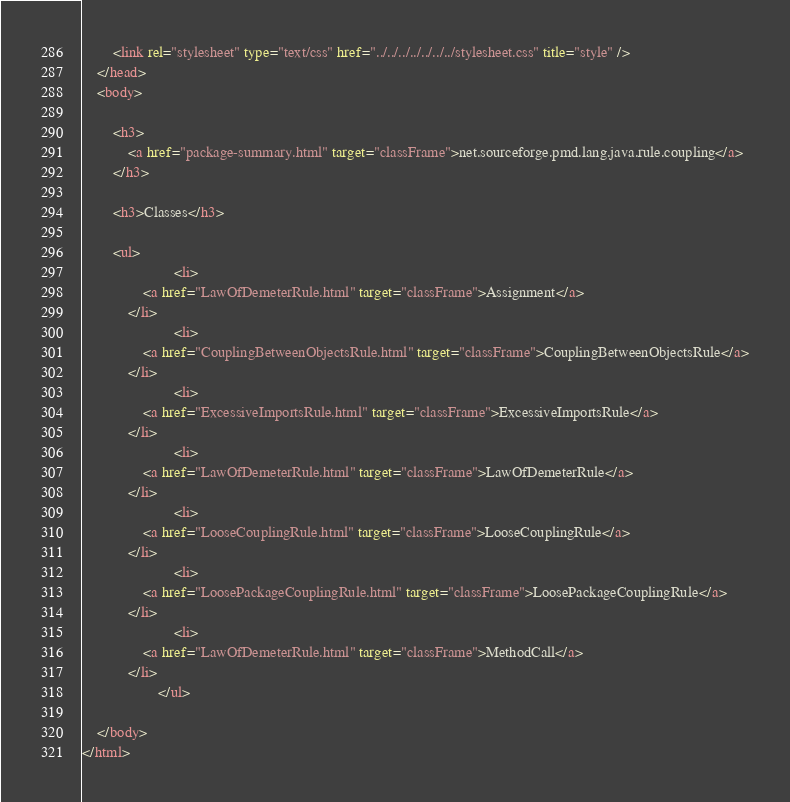Convert code to text. <code><loc_0><loc_0><loc_500><loc_500><_HTML_>		<link rel="stylesheet" type="text/css" href="../../../../../../../stylesheet.css" title="style" />
	</head>
	<body>

		<h3>
        	<a href="package-summary.html" target="classFrame">net.sourceforge.pmd.lang.java.rule.coupling</a>
      	</h3>

      	<h3>Classes</h3>

      	<ul>
      		          	<li>
            	<a href="LawOfDemeterRule.html" target="classFrame">Assignment</a>
          	</li>
          	          	<li>
            	<a href="CouplingBetweenObjectsRule.html" target="classFrame">CouplingBetweenObjectsRule</a>
          	</li>
          	          	<li>
            	<a href="ExcessiveImportsRule.html" target="classFrame">ExcessiveImportsRule</a>
          	</li>
          	          	<li>
            	<a href="LawOfDemeterRule.html" target="classFrame">LawOfDemeterRule</a>
          	</li>
          	          	<li>
            	<a href="LooseCouplingRule.html" target="classFrame">LooseCouplingRule</a>
          	</li>
          	          	<li>
            	<a href="LoosePackageCouplingRule.html" target="classFrame">LoosePackageCouplingRule</a>
          	</li>
          	          	<li>
            	<a href="LawOfDemeterRule.html" target="classFrame">MethodCall</a>
          	</li>
          	      	</ul>

	</body>
</html></code> 